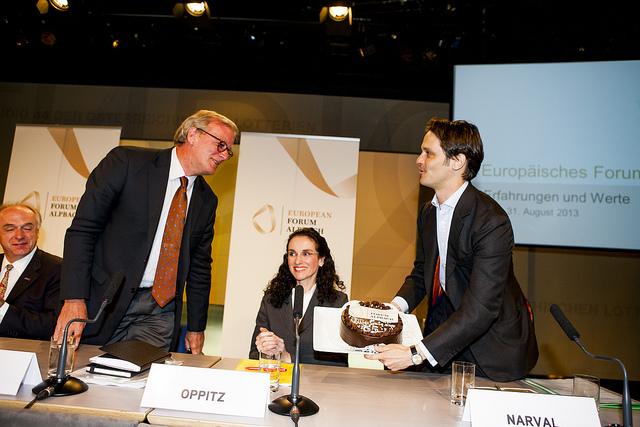How many men in suits are there?
Keep it brief. 3. Are there signs with their names?
Short answer required. Yes. Is this a conference?
Quick response, please. Yes. Why is the woman smiling?
Concise answer only. Happy. 